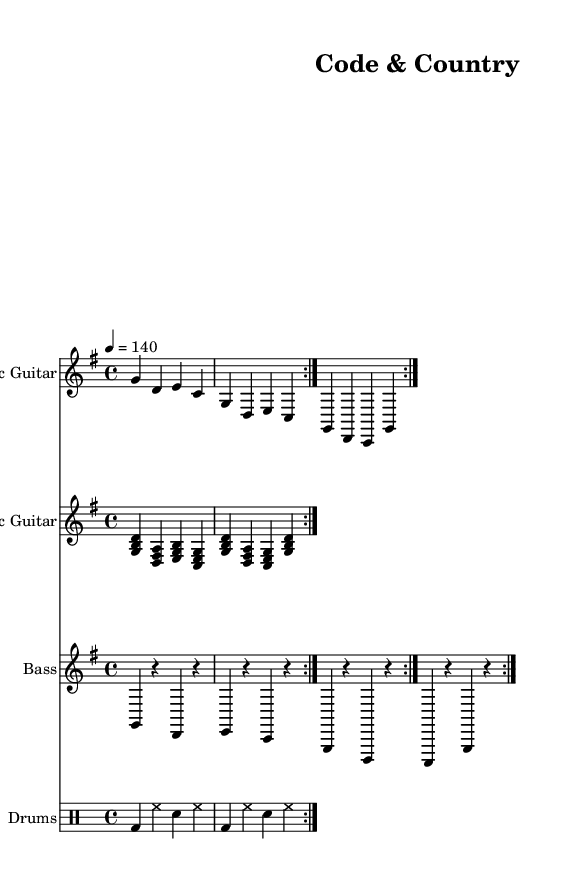What is the key signature of this music? The key signature is G major, which has one sharp (F#). It can be identified by looking at the key signature at the beginning of the staff where there is the sharp symbol.
Answer: G major What is the time signature of this piece? The time signature is 4/4, indicated at the beginning of the score. This tells us that there are four beats in each measure and the quarter note gets one beat.
Answer: 4/4 What is the tempo marking for this track? The tempo marking at the beginning indicates 140 beats per minute, shown by the number "4 = 140" which means a quarter note is played at 140 beats per minute.
Answer: 140 How many measures are repeated in the electric guitar part? The electric guitar part contains a repeat indication after the first section. Counting the measures before the repeat shows there are four measures in total played twice.
Answer: 2 What type of guitar is featured in the second staff? The second staff is labeled "Acoustic Guitar," which can be determined by the title directly above the staff and the use of chords typical for acoustic playing.
Answer: Acoustic Guitar Which drum sounds are specified in the drum part? The drum part features bass drum (bd), hi-hat (hh), and snare drum (sn) as indicated in the drum notation within the drum staff, representing the common elements in a rhythm section.
Answer: Bass drum, hi-hat, snare 